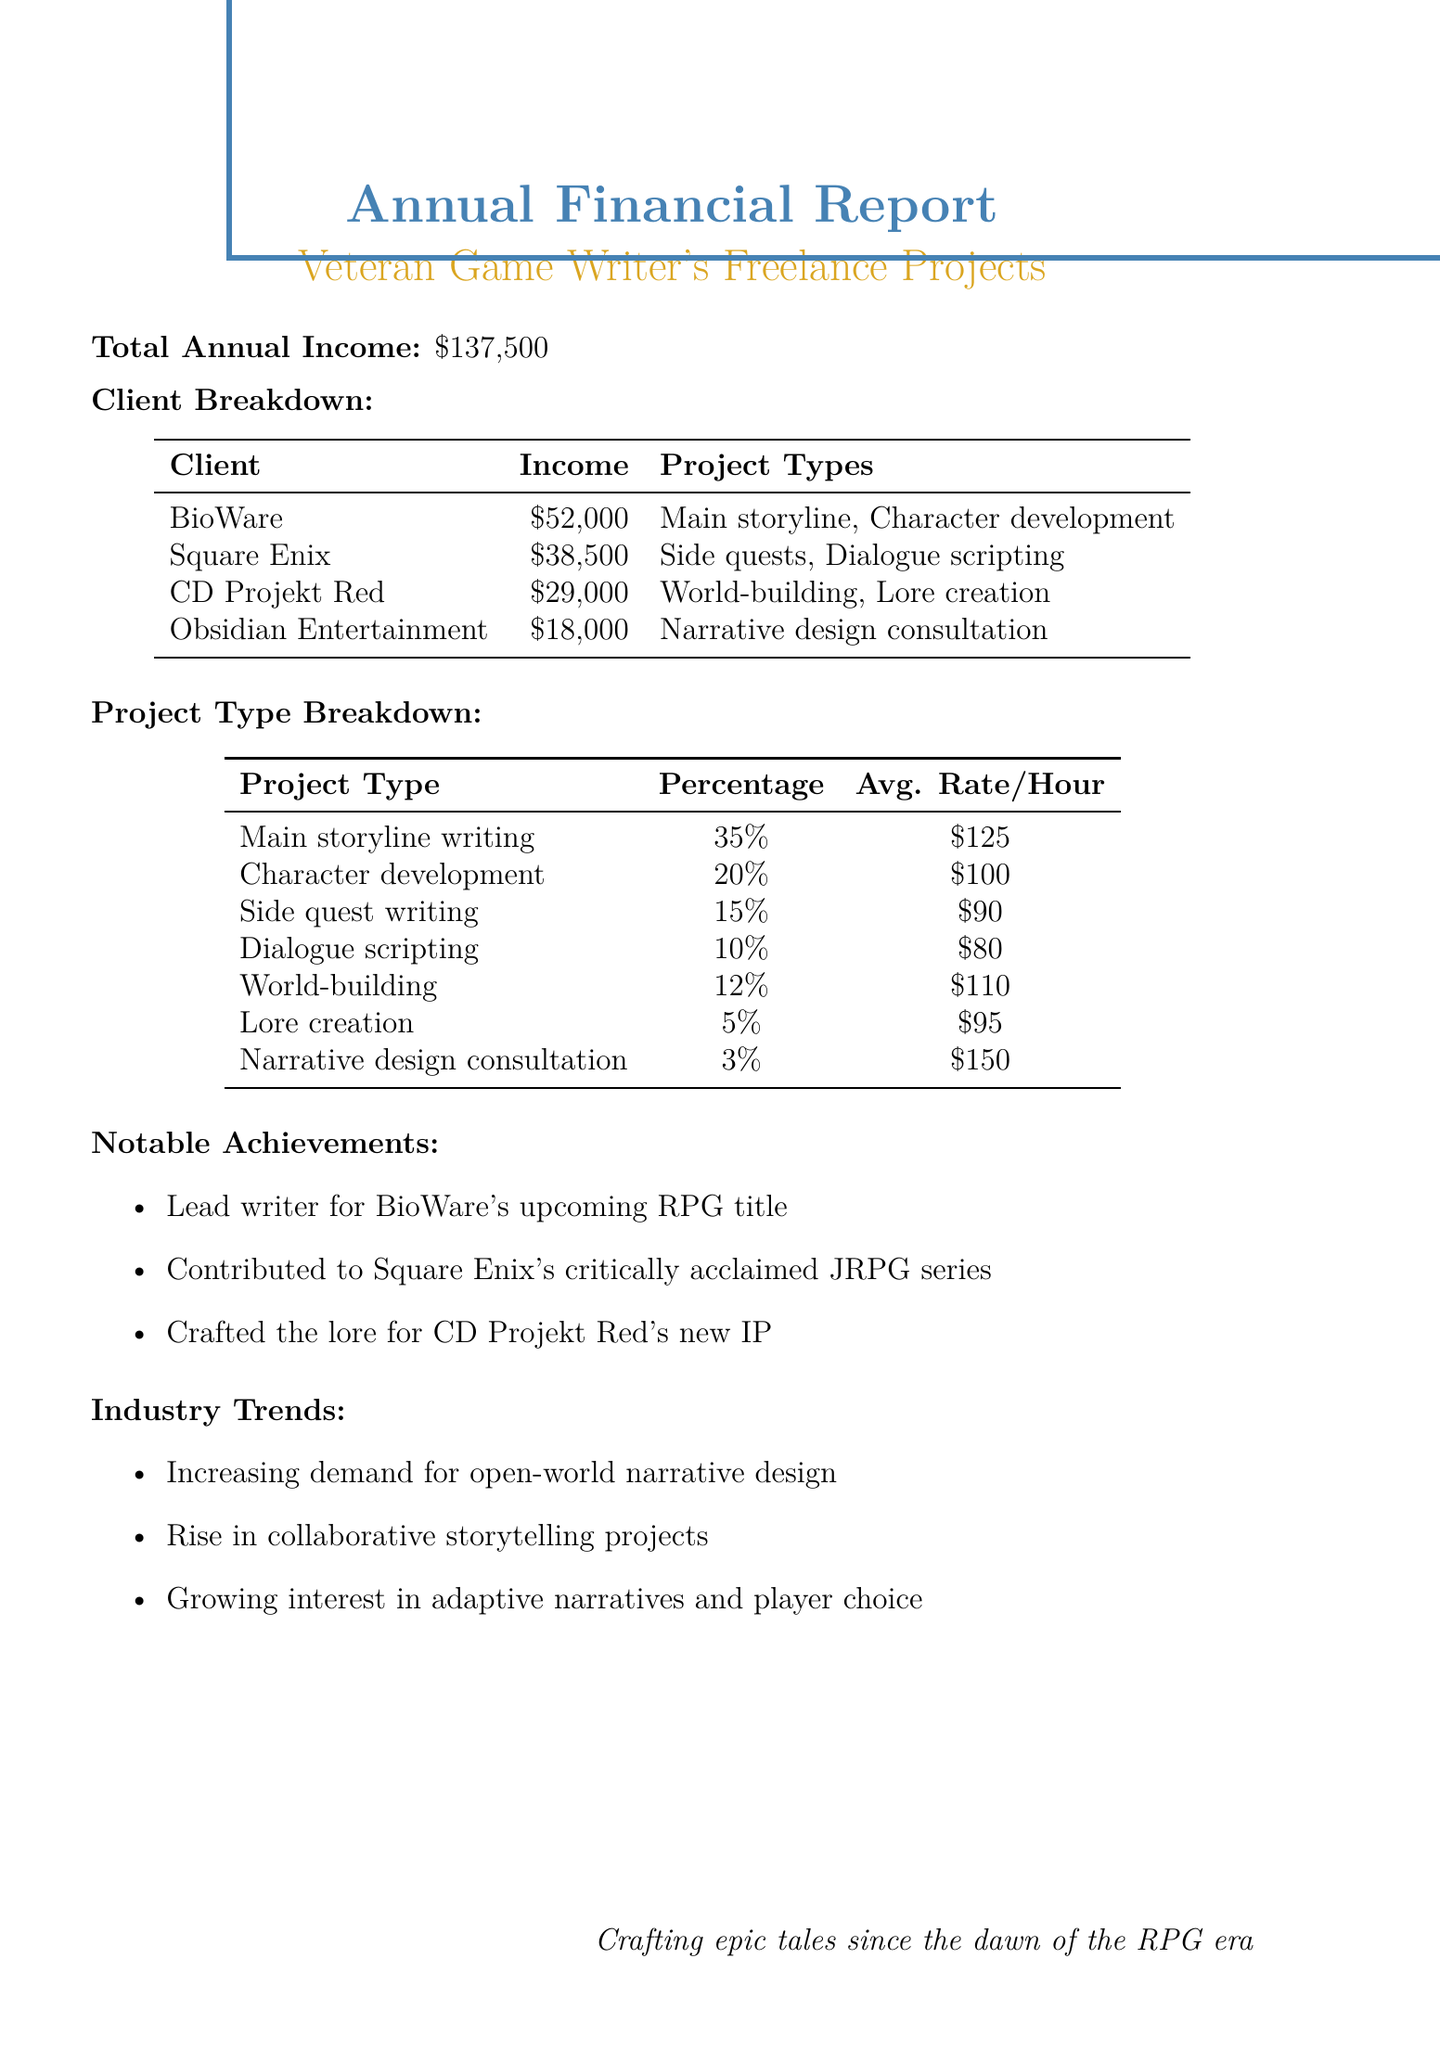What is the total annual income? The total annual income is stated at the beginning of the document, which amounts to $137,500.
Answer: $137,500 Which client contributed the most income? The client with the highest income is identified in the client breakdown section, where BioWare is listed with $52,000.
Answer: BioWare What percentage of income came from character development? The project type breakdown specifies that character development constitutes 20% of the total income.
Answer: 20% What is the average rate per hour for narrative design consultation? The project type breakdown provides the average rate per hour for narrative design consultation, which is $150.
Answer: $150 How many notable achievements are listed? The notable achievements section presents a list of accomplishments, totaling three specific items.
Answer: 3 Which project type has the lowest income percentage? The project type breakdown reveals that narrative design consultation has the lowest income percentage at 3%.
Answer: 3% Which company is associated with lore creation? The client breakdown indicates that CD Projekt Red is the company associated with lore creation.
Answer: CD Projekt Red What is the average income from Square Enix? The income for Square Enix is clearly listed in the document, showing a total of $38,500.
Answer: $38,500 What is the overall trend mentioned in the industry trends section? The industry trends section highlights the increasing demand for open-world narrative design as a significant trend.
Answer: Increasing demand for open-world narrative design 